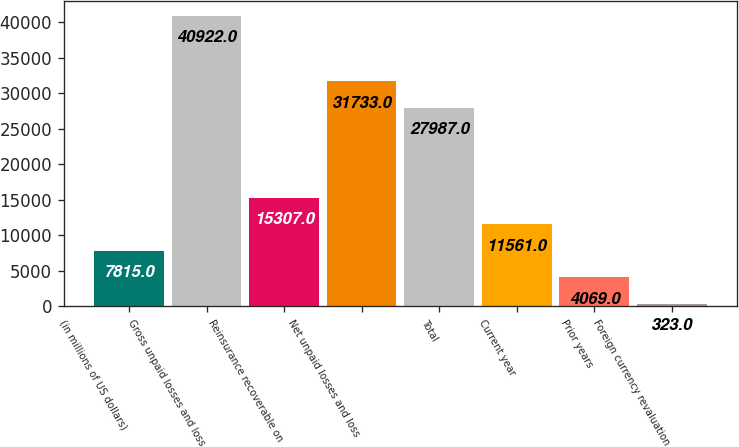Convert chart. <chart><loc_0><loc_0><loc_500><loc_500><bar_chart><fcel>(in millions of US dollars)<fcel>Gross unpaid losses and loss<fcel>Reinsurance recoverable on<fcel>Net unpaid losses and loss<fcel>Total<fcel>Current year<fcel>Prior years<fcel>Foreign currency revaluation<nl><fcel>7815<fcel>40922<fcel>15307<fcel>31733<fcel>27987<fcel>11561<fcel>4069<fcel>323<nl></chart> 